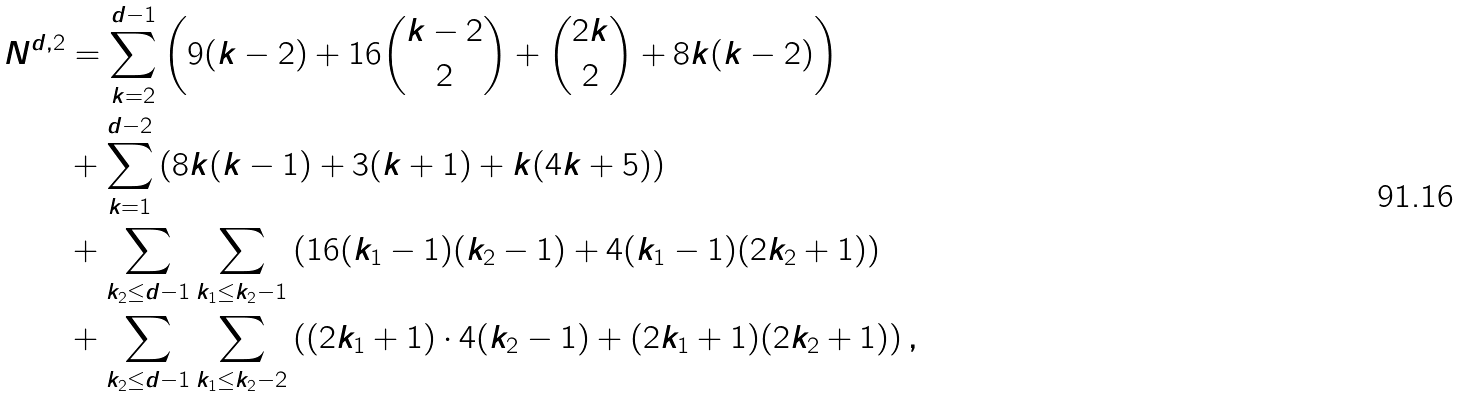Convert formula to latex. <formula><loc_0><loc_0><loc_500><loc_500>N ^ { d , 2 } & = \sum _ { k = 2 } ^ { d - 1 } \left ( 9 ( k - 2 ) + 1 6 \binom { k - 2 } { 2 } + \binom { 2 k } { 2 } + 8 k ( k - 2 ) \right ) \\ & + \sum _ { k = 1 } ^ { d - 2 } \left ( 8 k ( k - 1 ) + 3 ( k + 1 ) + k ( 4 k + 5 ) \right ) \\ & + \sum _ { k _ { 2 } \leq d - 1 } \sum _ { k _ { 1 } \leq k _ { 2 } - 1 } \left ( 1 6 ( k _ { 1 } - 1 ) ( k _ { 2 } - 1 ) + 4 ( k _ { 1 } - 1 ) ( 2 k _ { 2 } + 1 ) \right ) \\ & + \sum _ { k _ { 2 } \leq d - 1 } \sum _ { k _ { 1 } \leq k _ { 2 } - 2 } \left ( ( 2 k _ { 1 } + 1 ) \cdot 4 ( k _ { 2 } - 1 ) + ( 2 k _ { 1 } + 1 ) ( 2 k _ { 2 } + 1 ) \right ) ,</formula> 